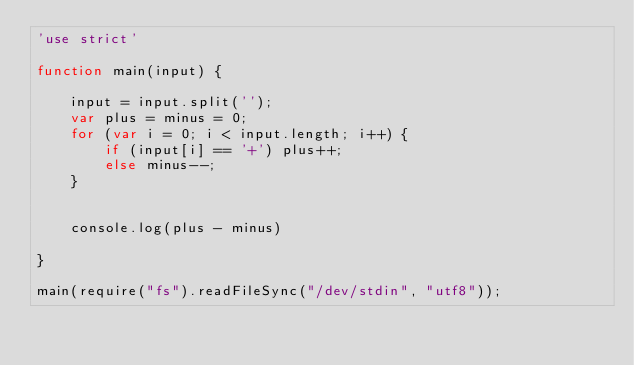<code> <loc_0><loc_0><loc_500><loc_500><_JavaScript_>'use strict'

function main(input) {

    input = input.split('');
    var plus = minus = 0;
    for (var i = 0; i < input.length; i++) {
        if (input[i] == '+') plus++;
        else minus--;
    }


    console.log(plus - minus)

}

main(require("fs").readFileSync("/dev/stdin", "utf8"));
</code> 